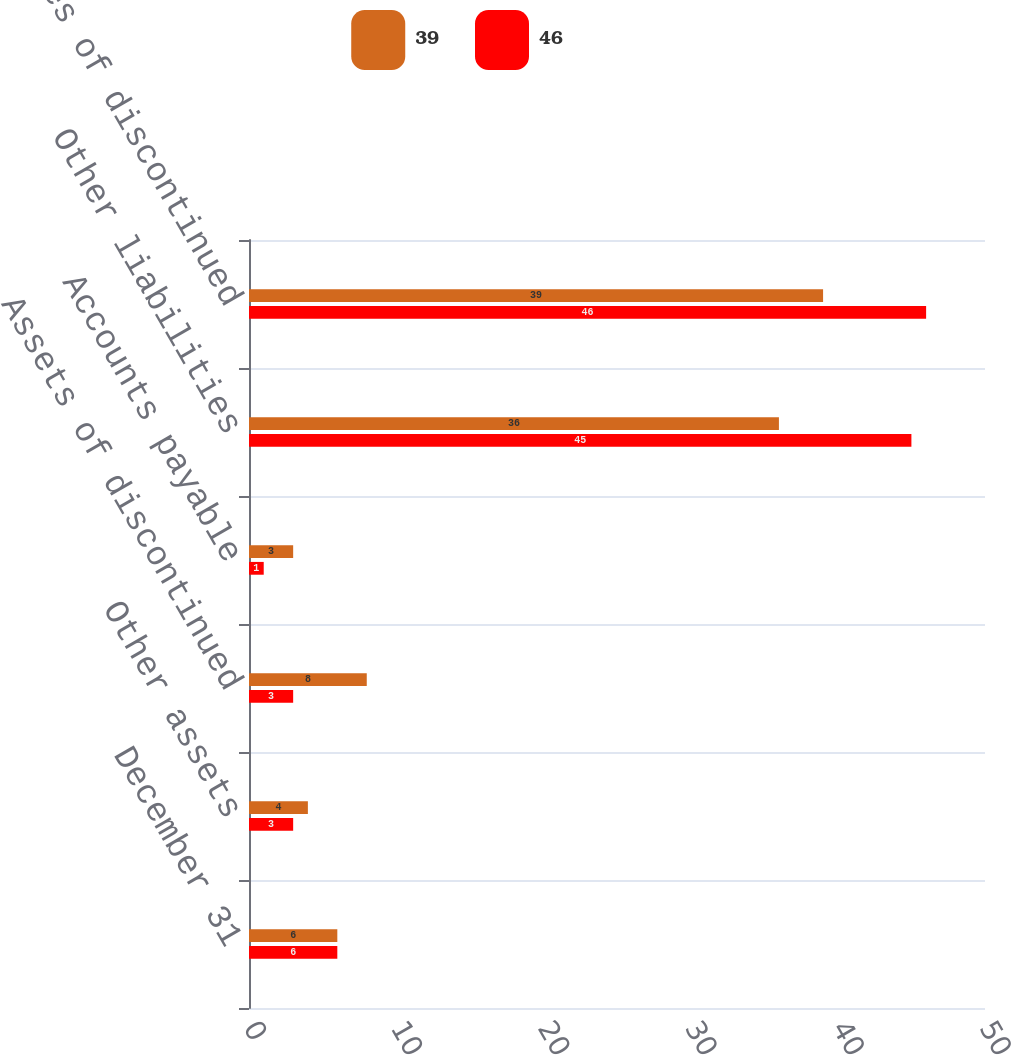<chart> <loc_0><loc_0><loc_500><loc_500><stacked_bar_chart><ecel><fcel>December 31<fcel>Other assets<fcel>Assets of discontinued<fcel>Accounts payable<fcel>Other liabilities<fcel>Liabilities of discontinued<nl><fcel>39<fcel>6<fcel>4<fcel>8<fcel>3<fcel>36<fcel>39<nl><fcel>46<fcel>6<fcel>3<fcel>3<fcel>1<fcel>45<fcel>46<nl></chart> 